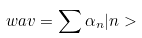Convert formula to latex. <formula><loc_0><loc_0><loc_500><loc_500>\ w a v = \sum \alpha _ { n } | n ></formula> 